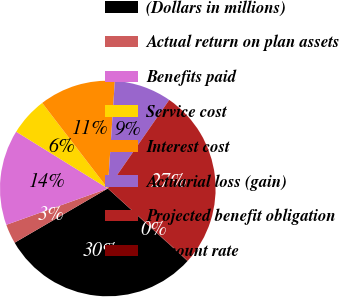Convert chart. <chart><loc_0><loc_0><loc_500><loc_500><pie_chart><fcel>(Dollars in millions)<fcel>Actual return on plan assets<fcel>Benefits paid<fcel>Service cost<fcel>Interest cost<fcel>Actuarial loss (gain)<fcel>Projected benefit obligation<fcel>Discount rate<nl><fcel>29.87%<fcel>2.92%<fcel>14.3%<fcel>5.76%<fcel>11.45%<fcel>8.61%<fcel>27.02%<fcel>0.07%<nl></chart> 